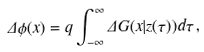Convert formula to latex. <formula><loc_0><loc_0><loc_500><loc_500>\Delta \phi ( x ) = q \int _ { - \infty } ^ { \infty } \Delta G ( x | z ( \tau ) ) d \tau \, ,</formula> 